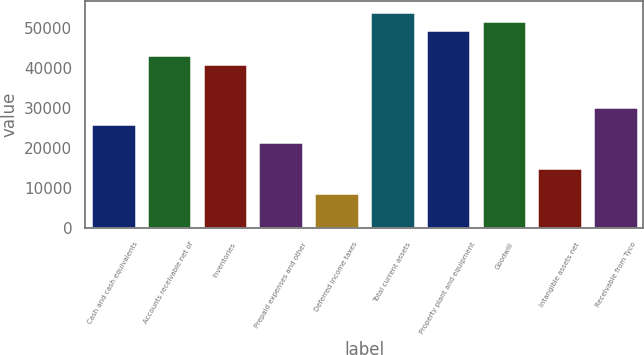Convert chart. <chart><loc_0><loc_0><loc_500><loc_500><bar_chart><fcel>Cash and cash equivalents<fcel>Accounts receivable net of<fcel>Inventories<fcel>Prepaid expenses and other<fcel>Deferred income taxes<fcel>Total current assets<fcel>Property plant and equipment<fcel>Goodwill<fcel>Intangible assets net<fcel>Receivable from Tyco<nl><fcel>25918<fcel>43190<fcel>41031<fcel>21600<fcel>8646<fcel>53985<fcel>49667<fcel>51826<fcel>15123<fcel>30236<nl></chart> 